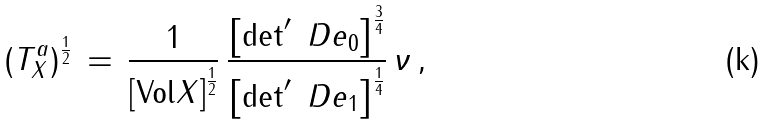<formula> <loc_0><loc_0><loc_500><loc_500>( T _ { X } ^ { a } ) ^ { \frac { 1 } { 2 } } \, = \, \frac { 1 } { \left [ \text {Vol} X \right ] ^ { \frac { 1 } { 2 } } } \, \frac { \left [ \det ^ { \prime } \ D e _ { 0 } \right ] ^ { \frac { 3 } { 4 } } } { \left [ \det ^ { \prime } \ D e _ { 1 } \right ] ^ { \frac { 1 } { 4 } } } \, \nu \, ,</formula> 